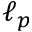Convert formula to latex. <formula><loc_0><loc_0><loc_500><loc_500>\ell _ { p }</formula> 